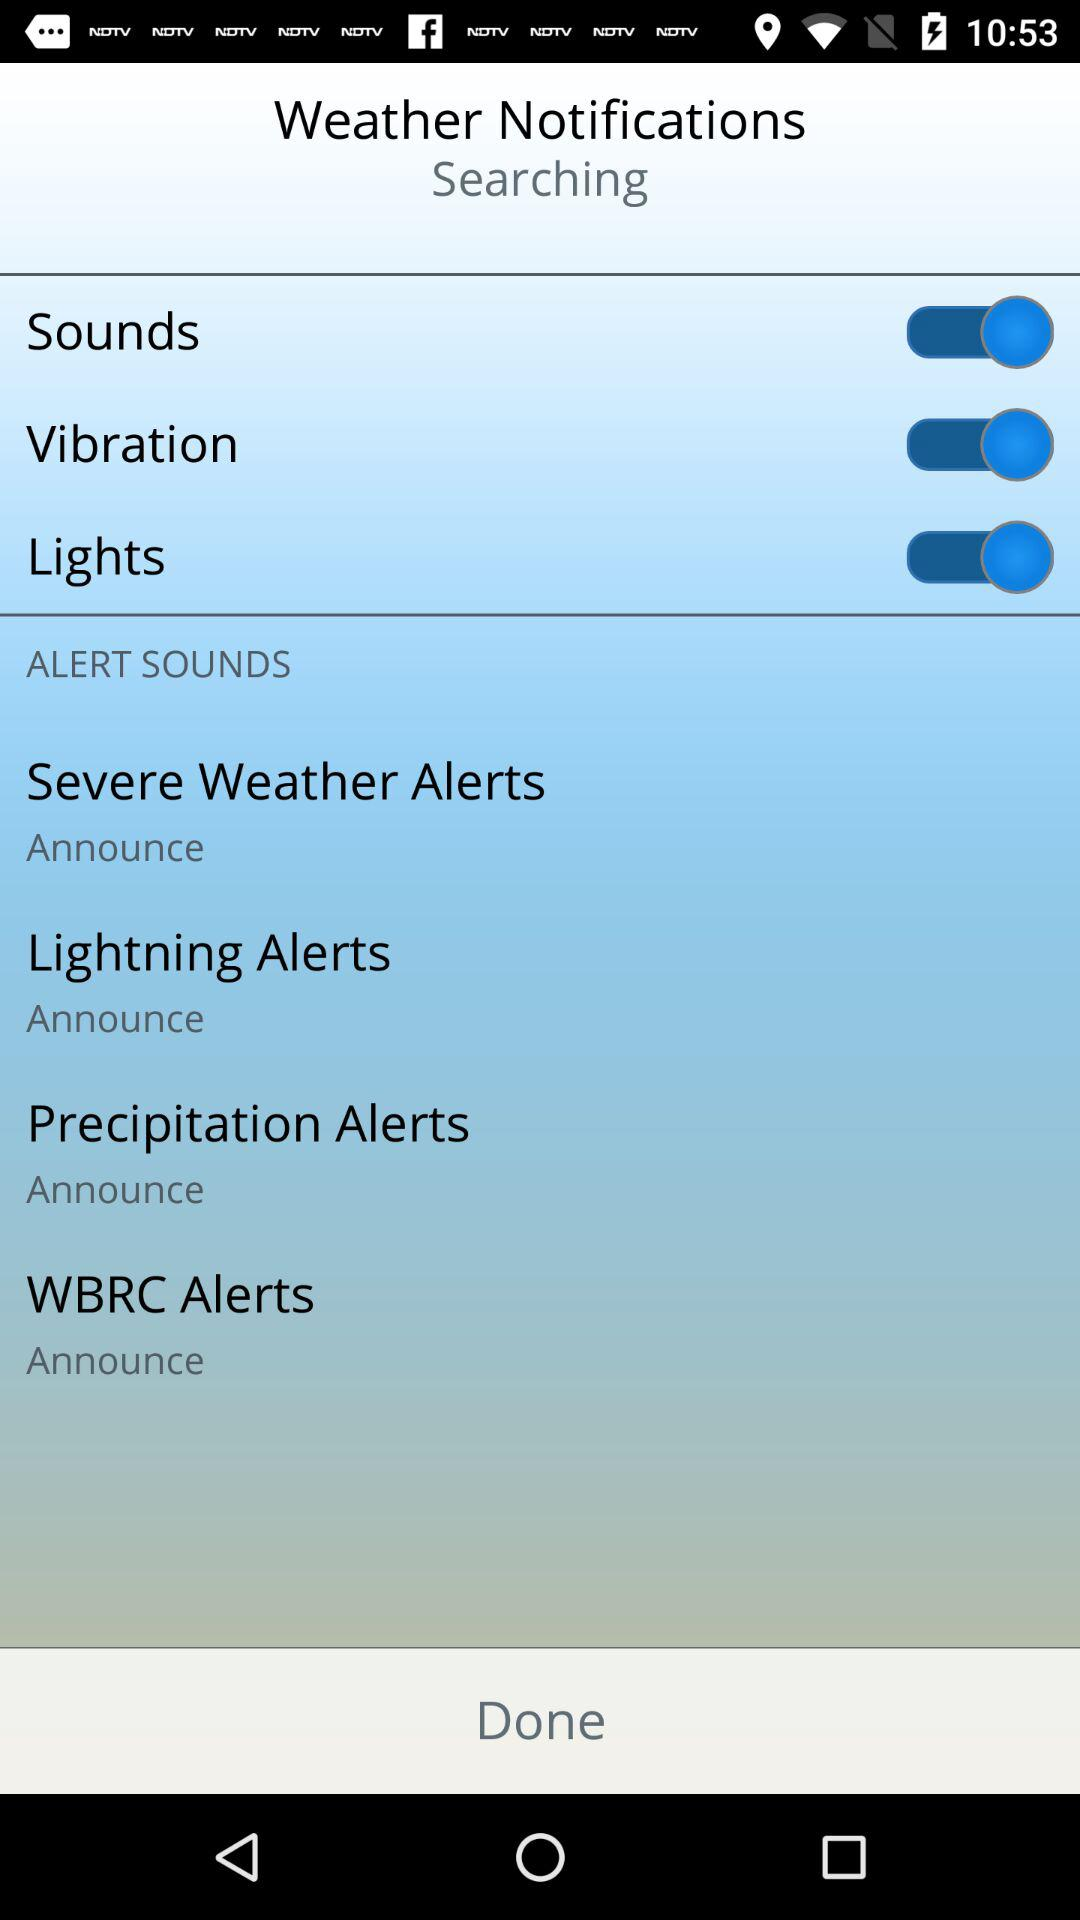How many alert sounds are available?
Answer the question using a single word or phrase. 4 